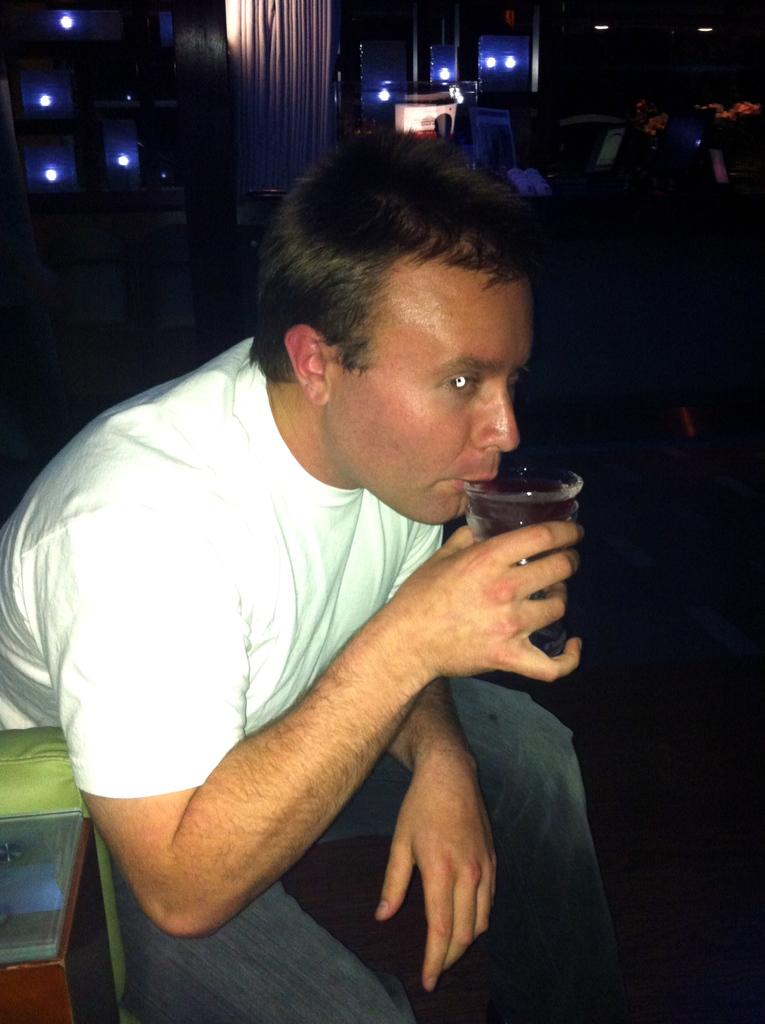What is the person in the image doing? The person is drinking liquid from a glass. What is the person using to drink the liquid? The person is using a glass to drink the liquid. What can be seen on the left side of the image? There is an object on the left side of the image. What type of illumination is present in the image? There are lights visible in the image. What is visible in the background of the image? There are objects present in the background of the image. What type of songs is the carpenter singing in the image? There is no carpenter or singing present in the image. 